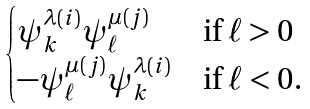<formula> <loc_0><loc_0><loc_500><loc_500>\begin{cases} \psi ^ { \lambda ( i ) } _ { k } \psi ^ { \mu ( j ) } _ { \ell } \ & \text {if} \ \ell > 0 \\ - \psi ^ { \mu ( j ) } _ { \ell } \psi ^ { \lambda ( i ) } _ { k } & \text {if} \ \ell < 0 . \end{cases}</formula> 